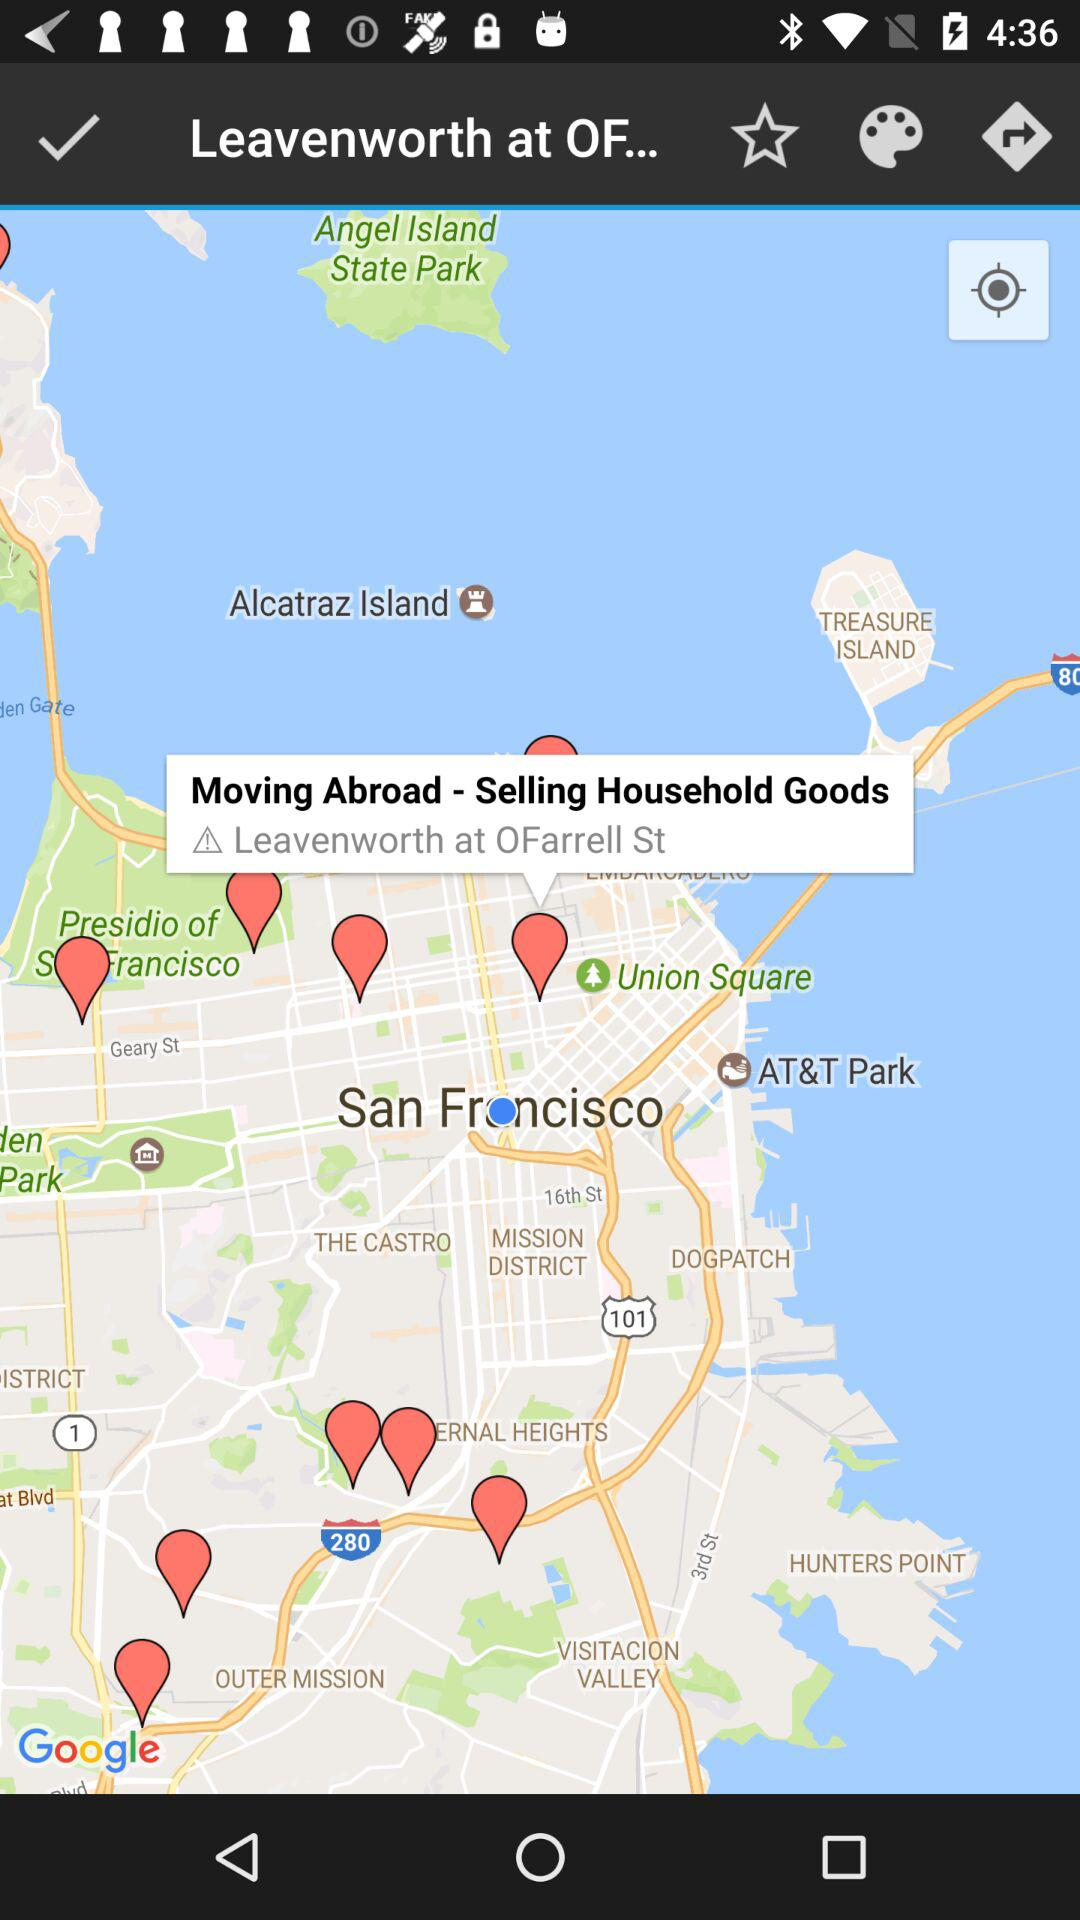What is the selected location? The selected location is Leavenworth at OFarrell St. 